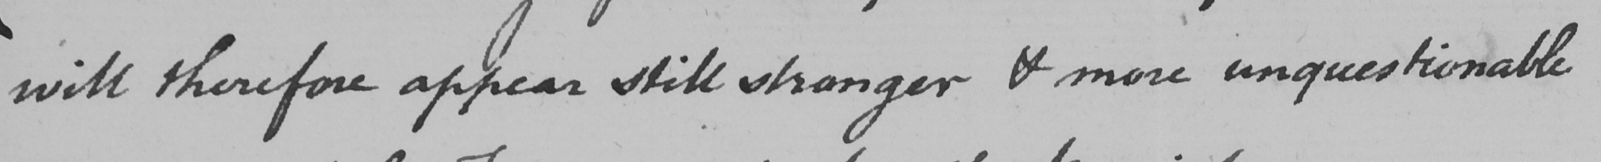Please transcribe the handwritten text in this image. will therefore appear still stronger & more unquestionable 